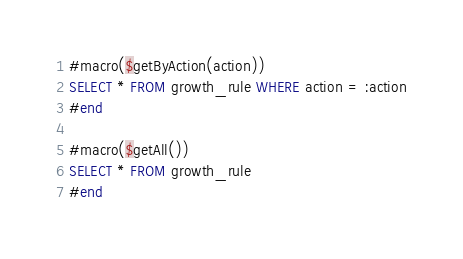Convert code to text. <code><loc_0><loc_0><loc_500><loc_500><_SQL_>#macro($getByAction(action))
SELECT * FROM growth_rule WHERE action = :action
#end

#macro($getAll())
SELECT * FROM growth_rule
#end</code> 